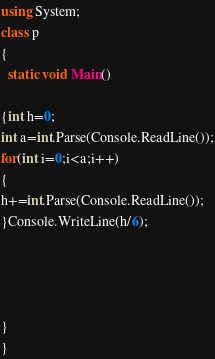Convert code to text. <code><loc_0><loc_0><loc_500><loc_500><_C#_>using System;
class p
{
  static void Main()

{int h=0;
int a=int.Parse(Console.ReadLine());
for(int i=0;i<a;i++)
{
h+=int.Parse(Console.ReadLine());
}Console.WriteLine(h/6);




}
}</code> 